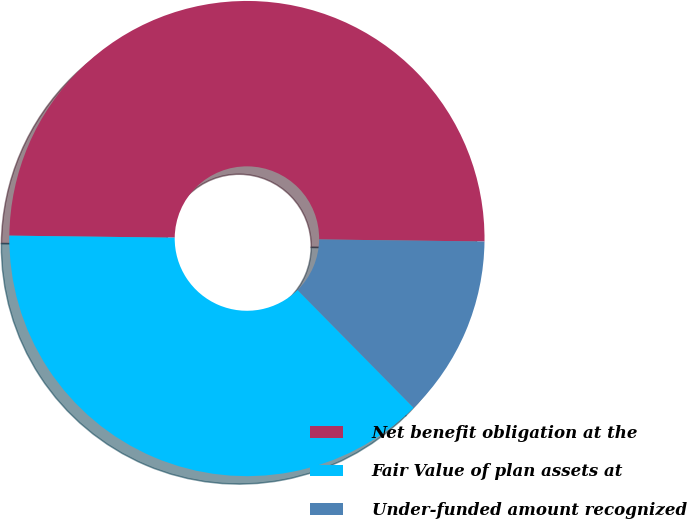<chart> <loc_0><loc_0><loc_500><loc_500><pie_chart><fcel>Net benefit obligation at the<fcel>Fair Value of plan assets at<fcel>Under-funded amount recognized<nl><fcel>50.0%<fcel>37.58%<fcel>12.42%<nl></chart> 